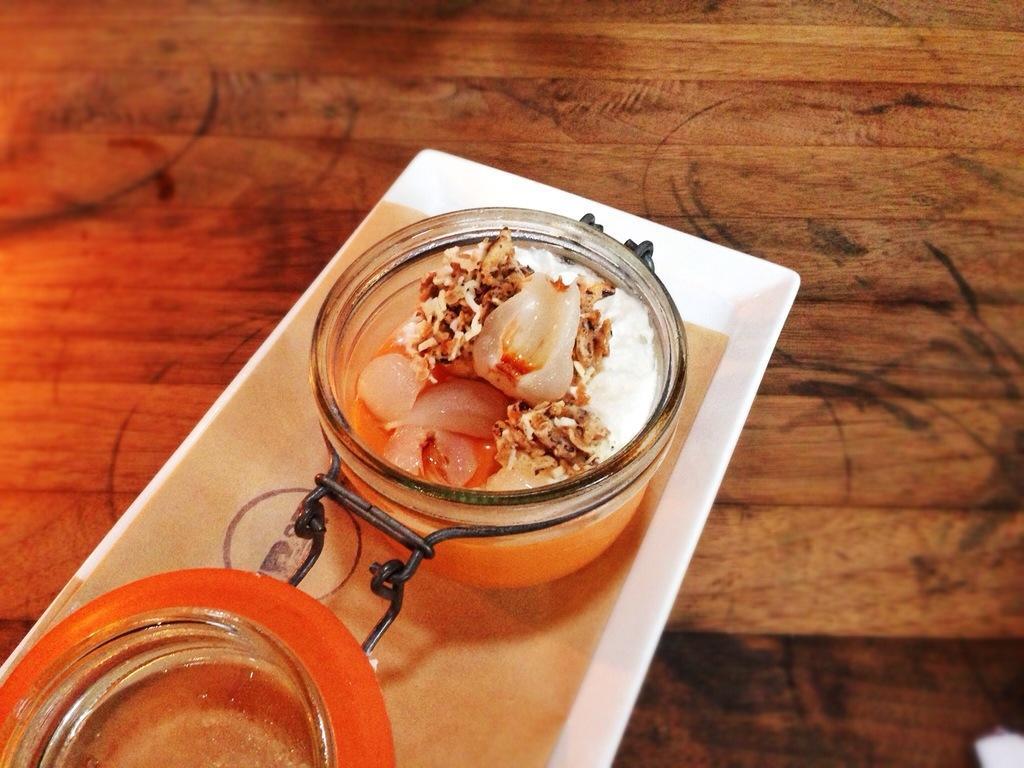Please provide a concise description of this image. In this image we can see a white plate on a wooden surface. On that there is a glass vessel with a food item. Also there is another bowl on a orange plate. 